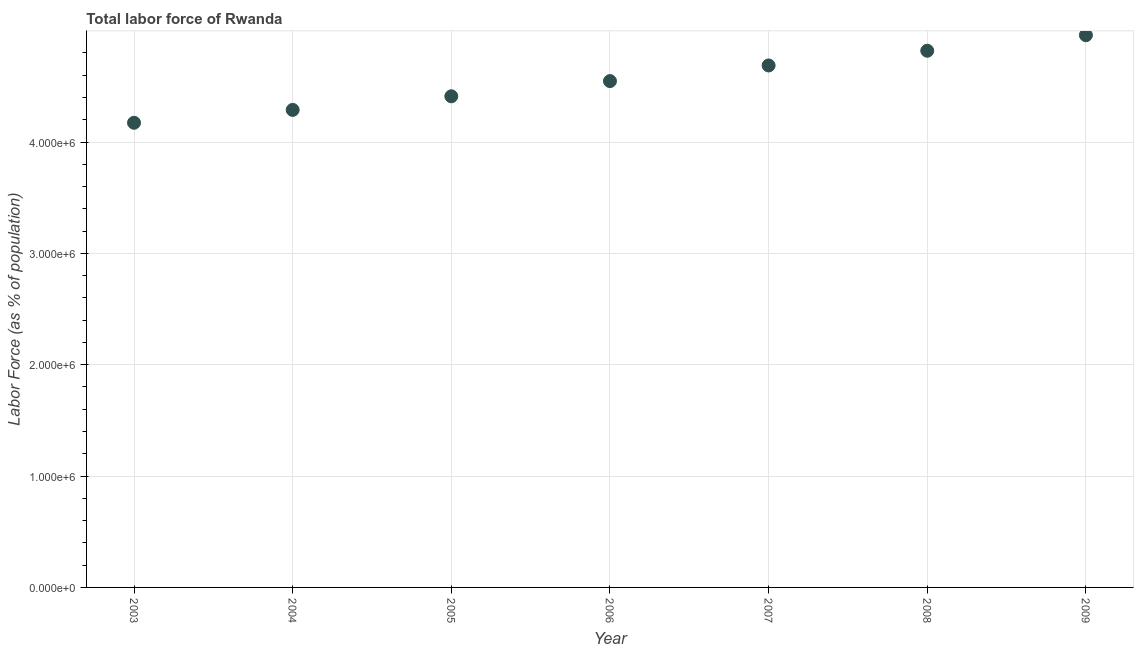What is the total labor force in 2005?
Offer a very short reply. 4.41e+06. Across all years, what is the maximum total labor force?
Provide a succinct answer. 4.96e+06. Across all years, what is the minimum total labor force?
Ensure brevity in your answer.  4.17e+06. In which year was the total labor force minimum?
Offer a very short reply. 2003. What is the sum of the total labor force?
Offer a very short reply. 3.19e+07. What is the difference between the total labor force in 2005 and 2006?
Provide a short and direct response. -1.36e+05. What is the average total labor force per year?
Provide a short and direct response. 4.55e+06. What is the median total labor force?
Give a very brief answer. 4.55e+06. What is the ratio of the total labor force in 2008 to that in 2009?
Provide a succinct answer. 0.97. Is the difference between the total labor force in 2004 and 2008 greater than the difference between any two years?
Your response must be concise. No. What is the difference between the highest and the second highest total labor force?
Offer a terse response. 1.40e+05. Is the sum of the total labor force in 2003 and 2007 greater than the maximum total labor force across all years?
Your answer should be very brief. Yes. What is the difference between the highest and the lowest total labor force?
Keep it short and to the point. 7.86e+05. In how many years, is the total labor force greater than the average total labor force taken over all years?
Provide a succinct answer. 3. How many years are there in the graph?
Provide a short and direct response. 7. What is the difference between two consecutive major ticks on the Y-axis?
Ensure brevity in your answer.  1.00e+06. Are the values on the major ticks of Y-axis written in scientific E-notation?
Your answer should be very brief. Yes. Does the graph contain any zero values?
Offer a very short reply. No. Does the graph contain grids?
Ensure brevity in your answer.  Yes. What is the title of the graph?
Your answer should be compact. Total labor force of Rwanda. What is the label or title of the Y-axis?
Offer a very short reply. Labor Force (as % of population). What is the Labor Force (as % of population) in 2003?
Give a very brief answer. 4.17e+06. What is the Labor Force (as % of population) in 2004?
Offer a terse response. 4.29e+06. What is the Labor Force (as % of population) in 2005?
Ensure brevity in your answer.  4.41e+06. What is the Labor Force (as % of population) in 2006?
Provide a succinct answer. 4.55e+06. What is the Labor Force (as % of population) in 2007?
Keep it short and to the point. 4.69e+06. What is the Labor Force (as % of population) in 2008?
Your answer should be compact. 4.82e+06. What is the Labor Force (as % of population) in 2009?
Your response must be concise. 4.96e+06. What is the difference between the Labor Force (as % of population) in 2003 and 2004?
Provide a short and direct response. -1.15e+05. What is the difference between the Labor Force (as % of population) in 2003 and 2005?
Make the answer very short. -2.38e+05. What is the difference between the Labor Force (as % of population) in 2003 and 2006?
Your answer should be very brief. -3.74e+05. What is the difference between the Labor Force (as % of population) in 2003 and 2007?
Your answer should be very brief. -5.15e+05. What is the difference between the Labor Force (as % of population) in 2003 and 2008?
Provide a short and direct response. -6.47e+05. What is the difference between the Labor Force (as % of population) in 2003 and 2009?
Make the answer very short. -7.86e+05. What is the difference between the Labor Force (as % of population) in 2004 and 2005?
Make the answer very short. -1.22e+05. What is the difference between the Labor Force (as % of population) in 2004 and 2006?
Make the answer very short. -2.59e+05. What is the difference between the Labor Force (as % of population) in 2004 and 2007?
Provide a succinct answer. -3.99e+05. What is the difference between the Labor Force (as % of population) in 2004 and 2008?
Your answer should be very brief. -5.31e+05. What is the difference between the Labor Force (as % of population) in 2004 and 2009?
Your answer should be compact. -6.71e+05. What is the difference between the Labor Force (as % of population) in 2005 and 2006?
Provide a short and direct response. -1.36e+05. What is the difference between the Labor Force (as % of population) in 2005 and 2007?
Offer a very short reply. -2.77e+05. What is the difference between the Labor Force (as % of population) in 2005 and 2008?
Your response must be concise. -4.09e+05. What is the difference between the Labor Force (as % of population) in 2005 and 2009?
Provide a succinct answer. -5.49e+05. What is the difference between the Labor Force (as % of population) in 2006 and 2007?
Your answer should be very brief. -1.41e+05. What is the difference between the Labor Force (as % of population) in 2006 and 2008?
Your answer should be very brief. -2.73e+05. What is the difference between the Labor Force (as % of population) in 2006 and 2009?
Give a very brief answer. -4.12e+05. What is the difference between the Labor Force (as % of population) in 2007 and 2008?
Ensure brevity in your answer.  -1.32e+05. What is the difference between the Labor Force (as % of population) in 2007 and 2009?
Offer a terse response. -2.72e+05. What is the difference between the Labor Force (as % of population) in 2008 and 2009?
Ensure brevity in your answer.  -1.40e+05. What is the ratio of the Labor Force (as % of population) in 2003 to that in 2004?
Keep it short and to the point. 0.97. What is the ratio of the Labor Force (as % of population) in 2003 to that in 2005?
Make the answer very short. 0.95. What is the ratio of the Labor Force (as % of population) in 2003 to that in 2006?
Offer a terse response. 0.92. What is the ratio of the Labor Force (as % of population) in 2003 to that in 2007?
Make the answer very short. 0.89. What is the ratio of the Labor Force (as % of population) in 2003 to that in 2008?
Offer a very short reply. 0.87. What is the ratio of the Labor Force (as % of population) in 2003 to that in 2009?
Offer a terse response. 0.84. What is the ratio of the Labor Force (as % of population) in 2004 to that in 2006?
Provide a short and direct response. 0.94. What is the ratio of the Labor Force (as % of population) in 2004 to that in 2007?
Keep it short and to the point. 0.92. What is the ratio of the Labor Force (as % of population) in 2004 to that in 2008?
Make the answer very short. 0.89. What is the ratio of the Labor Force (as % of population) in 2004 to that in 2009?
Your answer should be very brief. 0.86. What is the ratio of the Labor Force (as % of population) in 2005 to that in 2007?
Your response must be concise. 0.94. What is the ratio of the Labor Force (as % of population) in 2005 to that in 2008?
Your response must be concise. 0.92. What is the ratio of the Labor Force (as % of population) in 2005 to that in 2009?
Offer a terse response. 0.89. What is the ratio of the Labor Force (as % of population) in 2006 to that in 2007?
Keep it short and to the point. 0.97. What is the ratio of the Labor Force (as % of population) in 2006 to that in 2008?
Ensure brevity in your answer.  0.94. What is the ratio of the Labor Force (as % of population) in 2006 to that in 2009?
Ensure brevity in your answer.  0.92. What is the ratio of the Labor Force (as % of population) in 2007 to that in 2008?
Offer a terse response. 0.97. What is the ratio of the Labor Force (as % of population) in 2007 to that in 2009?
Offer a very short reply. 0.94. What is the ratio of the Labor Force (as % of population) in 2008 to that in 2009?
Provide a short and direct response. 0.97. 